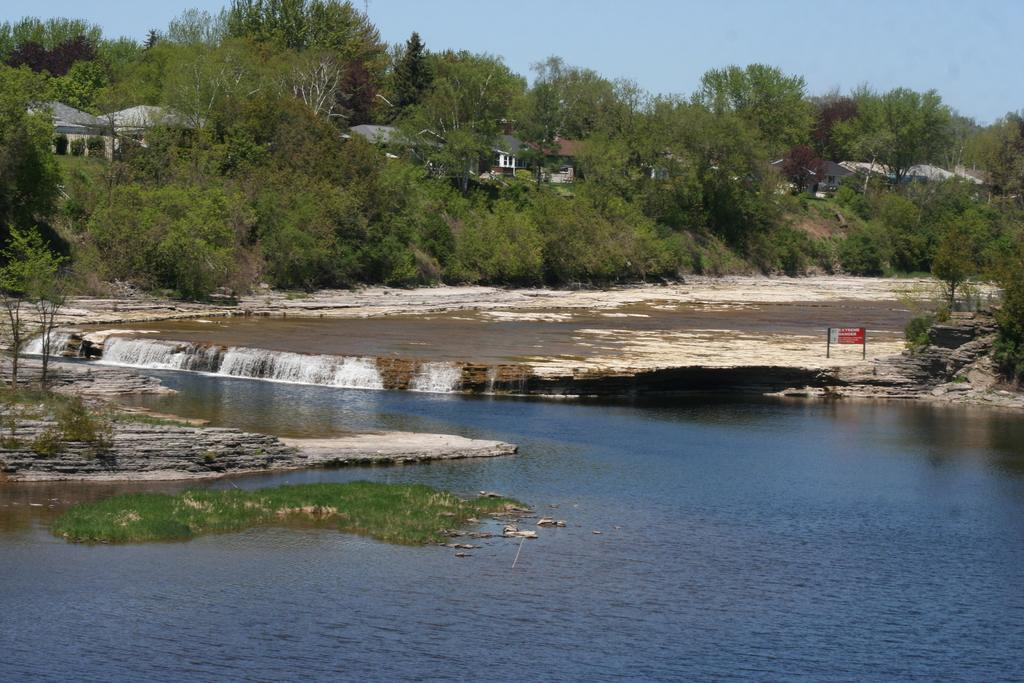What type of natural feature can be seen in the image? There is a river in the image. What structure might provide information to visitors in the image? There is an information board in the image. What type of vegetation is present in the image? There are trees in the image. What type of man-made structures can be seen in the image? There are buildings in the image. What is visible in the background of the image? The sky is visible in the image. What is the taste of the water in the river in the image? The taste of the water in the river cannot be determined from the image alone. --- 